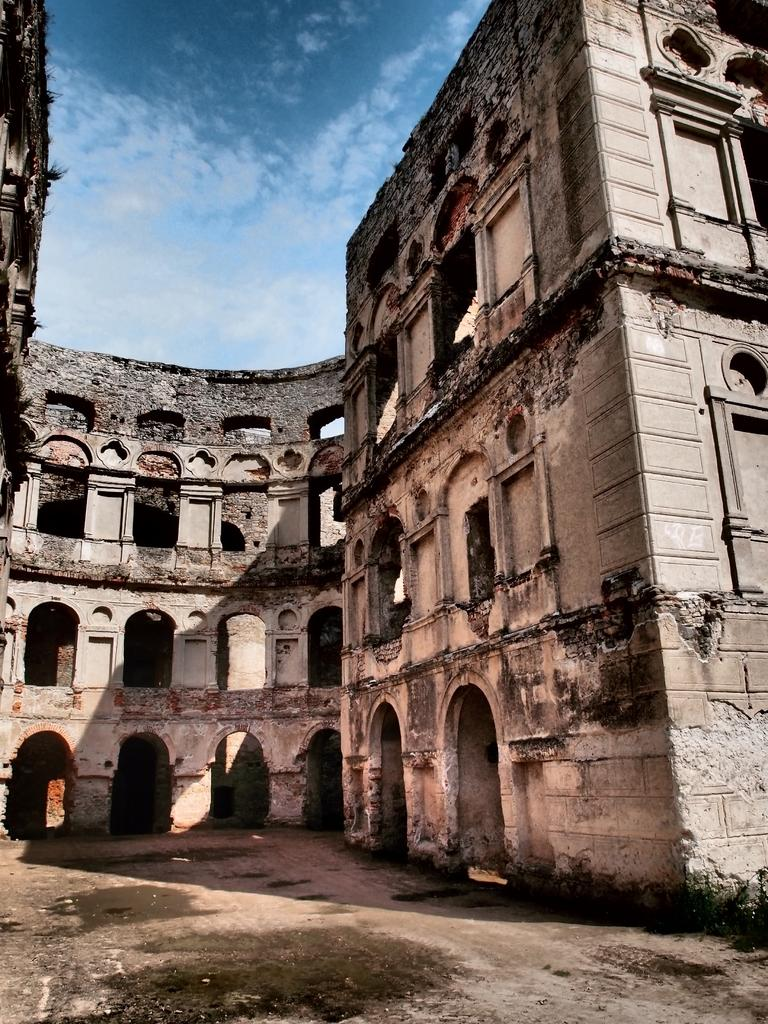What type of structure is visible in the picture? There is a building in the picture. What is the condition of the sky in the picture? The sky is cloudy in the picture. How many apples are floating in the water near the building in the picture? There are no apples or water visible in the picture; it only features a building and a cloudy sky. 